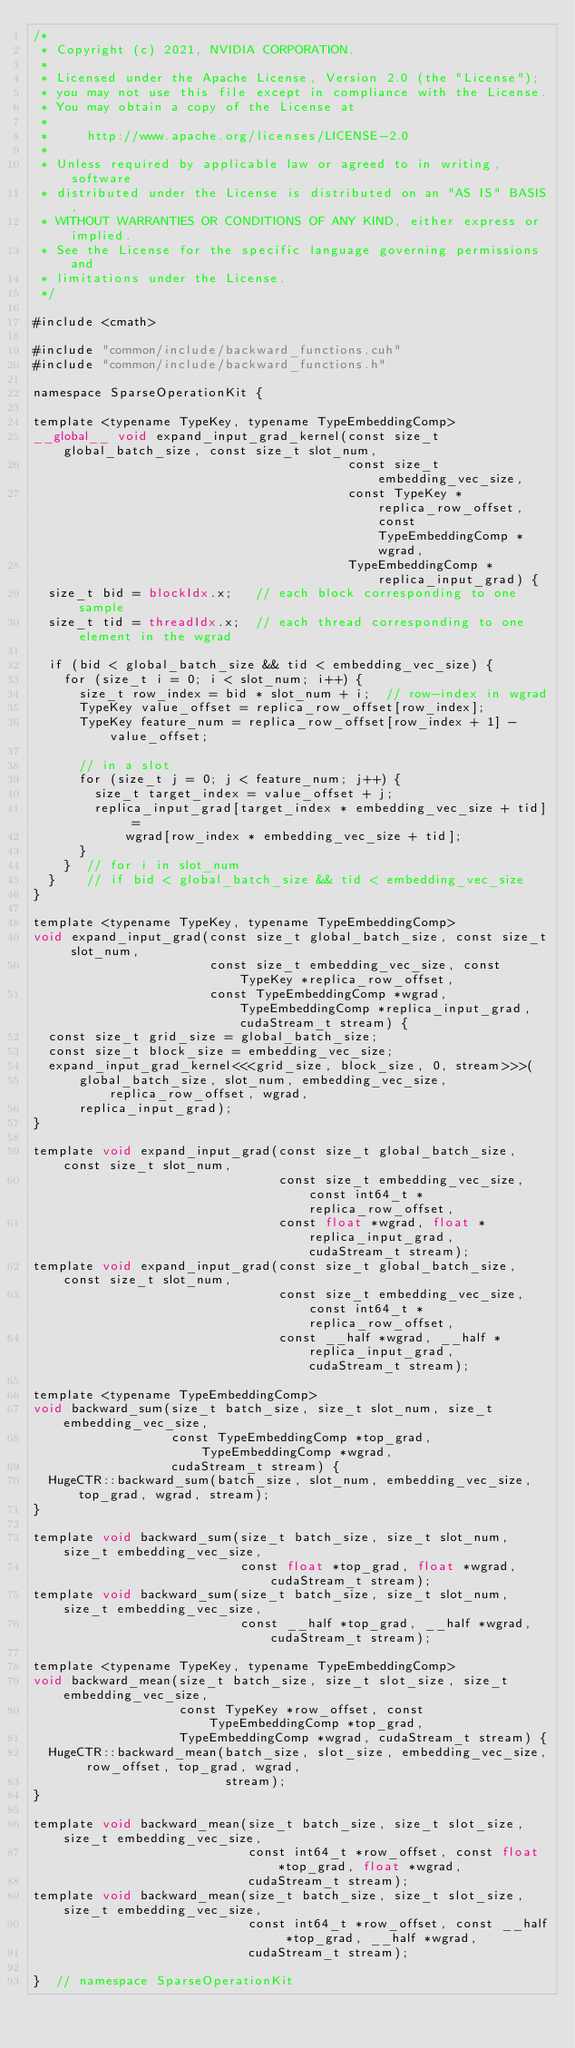Convert code to text. <code><loc_0><loc_0><loc_500><loc_500><_Cuda_>/*
 * Copyright (c) 2021, NVIDIA CORPORATION.
 *
 * Licensed under the Apache License, Version 2.0 (the "License");
 * you may not use this file except in compliance with the License.
 * You may obtain a copy of the License at
 *
 *     http://www.apache.org/licenses/LICENSE-2.0
 *
 * Unless required by applicable law or agreed to in writing, software
 * distributed under the License is distributed on an "AS IS" BASIS,
 * WITHOUT WARRANTIES OR CONDITIONS OF ANY KIND, either express or implied.
 * See the License for the specific language governing permissions and
 * limitations under the License.
 */

#include <cmath>

#include "common/include/backward_functions.cuh"
#include "common/include/backward_functions.h"

namespace SparseOperationKit {

template <typename TypeKey, typename TypeEmbeddingComp>
__global__ void expand_input_grad_kernel(const size_t global_batch_size, const size_t slot_num,
                                         const size_t embedding_vec_size,
                                         const TypeKey *replica_row_offset, const TypeEmbeddingComp *wgrad,
                                         TypeEmbeddingComp *replica_input_grad) {
  size_t bid = blockIdx.x;   // each block corresponding to one sample
  size_t tid = threadIdx.x;  // each thread corresponding to one element in the wgrad

  if (bid < global_batch_size && tid < embedding_vec_size) {
    for (size_t i = 0; i < slot_num; i++) {
      size_t row_index = bid * slot_num + i;  // row-index in wgrad
      TypeKey value_offset = replica_row_offset[row_index];
      TypeKey feature_num = replica_row_offset[row_index + 1] - value_offset;

      // in a slot
      for (size_t j = 0; j < feature_num; j++) {
        size_t target_index = value_offset + j;
        replica_input_grad[target_index * embedding_vec_size + tid] =
            wgrad[row_index * embedding_vec_size + tid];
      }
    }  // for i in slot_num
  }    // if bid < global_batch_size && tid < embedding_vec_size
}

template <typename TypeKey, typename TypeEmbeddingComp>
void expand_input_grad(const size_t global_batch_size, const size_t slot_num,
                       const size_t embedding_vec_size, const TypeKey *replica_row_offset,
                       const TypeEmbeddingComp *wgrad, TypeEmbeddingComp *replica_input_grad, cudaStream_t stream) {
  const size_t grid_size = global_batch_size;
  const size_t block_size = embedding_vec_size;
  expand_input_grad_kernel<<<grid_size, block_size, 0, stream>>>(
      global_batch_size, slot_num, embedding_vec_size, replica_row_offset, wgrad,
      replica_input_grad);
}

template void expand_input_grad(const size_t global_batch_size, const size_t slot_num,
                                const size_t embedding_vec_size, const int64_t *replica_row_offset,
                                const float *wgrad, float *replica_input_grad, cudaStream_t stream);
template void expand_input_grad(const size_t global_batch_size, const size_t slot_num,
                                const size_t embedding_vec_size, const int64_t *replica_row_offset,
                                const __half *wgrad, __half *replica_input_grad, cudaStream_t stream);

template <typename TypeEmbeddingComp>
void backward_sum(size_t batch_size, size_t slot_num, size_t embedding_vec_size,
                  const TypeEmbeddingComp *top_grad, TypeEmbeddingComp *wgrad,
                  cudaStream_t stream) {
  HugeCTR::backward_sum(batch_size, slot_num, embedding_vec_size, top_grad, wgrad, stream);
}

template void backward_sum(size_t batch_size, size_t slot_num, size_t embedding_vec_size,
                           const float *top_grad, float *wgrad, cudaStream_t stream);
template void backward_sum(size_t batch_size, size_t slot_num, size_t embedding_vec_size,
                           const __half *top_grad, __half *wgrad, cudaStream_t stream);

template <typename TypeKey, typename TypeEmbeddingComp>
void backward_mean(size_t batch_size, size_t slot_size, size_t embedding_vec_size,
                   const TypeKey *row_offset, const TypeEmbeddingComp *top_grad,
                   TypeEmbeddingComp *wgrad, cudaStream_t stream) {
  HugeCTR::backward_mean(batch_size, slot_size, embedding_vec_size, row_offset, top_grad, wgrad,
                         stream);
}

template void backward_mean(size_t batch_size, size_t slot_size, size_t embedding_vec_size,
                            const int64_t *row_offset, const float *top_grad, float *wgrad,
                            cudaStream_t stream);
template void backward_mean(size_t batch_size, size_t slot_size, size_t embedding_vec_size,
                            const int64_t *row_offset, const __half *top_grad, __half *wgrad,
                            cudaStream_t stream);

}  // namespace SparseOperationKit
</code> 